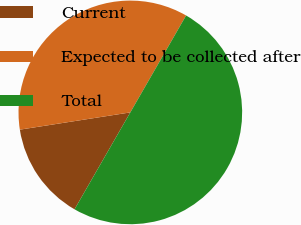Convert chart. <chart><loc_0><loc_0><loc_500><loc_500><pie_chart><fcel>Current<fcel>Expected to be collected after<fcel>Total<nl><fcel>14.22%<fcel>35.78%<fcel>50.0%<nl></chart> 